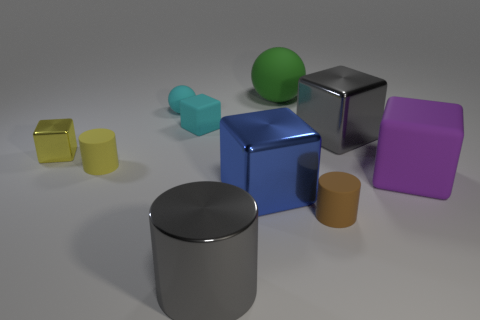How many objects are there in total within the image? In the image, there are a total of seven objects.  Can you describe the shapes and colors of the objects? Certainly! There's a yellow matte cube, a smaller teal cube, a blue metallic cube, a violet matte cube, a green matte sphere, a gray shiny cylinder, and a brown matte cylinder. Each object has a distinct shape and color, contributing to a vibrant assortment. 